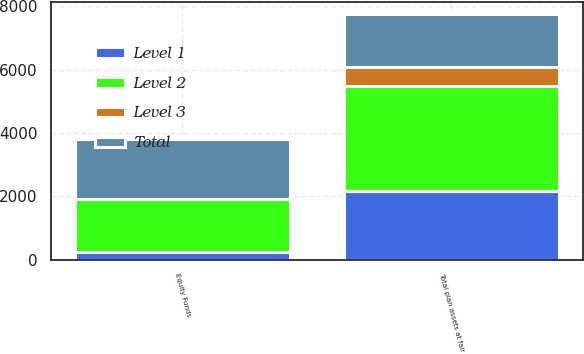Convert chart. <chart><loc_0><loc_0><loc_500><loc_500><stacked_bar_chart><ecel><fcel>Equity Funds<fcel>Total plan assets at fair<nl><fcel>Level 1<fcel>237<fcel>2164<nl><fcel>Level 2<fcel>1665<fcel>3320<nl><fcel>Level 3<fcel>7<fcel>597<nl><fcel>Total<fcel>1909<fcel>1665<nl></chart> 